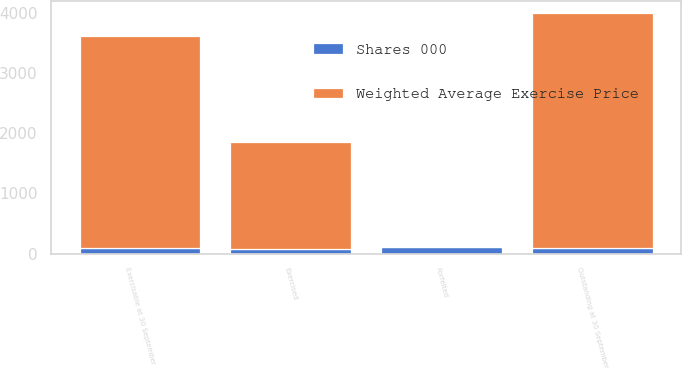Convert chart. <chart><loc_0><loc_0><loc_500><loc_500><stacked_bar_chart><ecel><fcel>Outstanding at 30 September<fcel>Exercised<fcel>Forfeited<fcel>Exercisable at 30 September<nl><fcel>Weighted Average Exercise Price<fcel>3916<fcel>1783<fcel>26<fcel>3537<nl><fcel>Shares 000<fcel>90.28<fcel>80.66<fcel>106.52<fcel>86.99<nl></chart> 